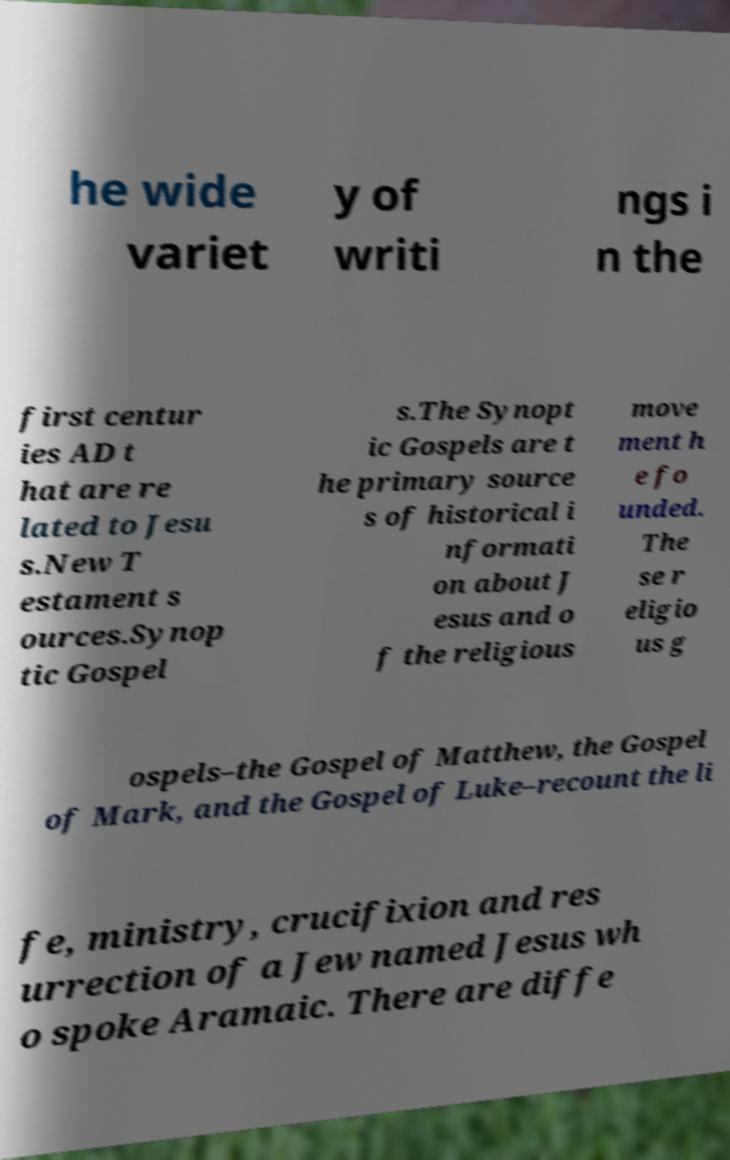There's text embedded in this image that I need extracted. Can you transcribe it verbatim? he wide variet y of writi ngs i n the first centur ies AD t hat are re lated to Jesu s.New T estament s ources.Synop tic Gospel s.The Synopt ic Gospels are t he primary source s of historical i nformati on about J esus and o f the religious move ment h e fo unded. The se r eligio us g ospels–the Gospel of Matthew, the Gospel of Mark, and the Gospel of Luke–recount the li fe, ministry, crucifixion and res urrection of a Jew named Jesus wh o spoke Aramaic. There are diffe 